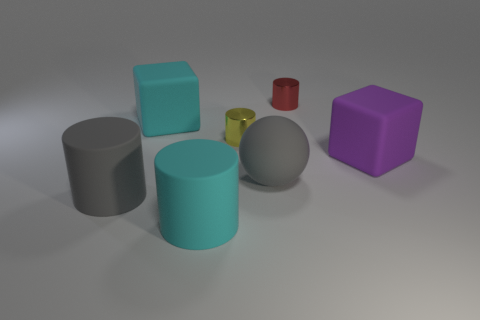What is the big gray cylinder in front of the metal cylinder on the left side of the shiny object that is right of the gray matte ball made of?
Keep it short and to the point. Rubber. Is the shape of the tiny object in front of the tiny red thing the same as the thing in front of the big gray rubber cylinder?
Keep it short and to the point. Yes. Is there a gray matte object of the same size as the cyan cube?
Offer a terse response. Yes. What number of red objects are either tiny cylinders or big balls?
Ensure brevity in your answer.  1. How many other balls are the same color as the large ball?
Ensure brevity in your answer.  0. Is there anything else that has the same shape as the yellow object?
Offer a very short reply. Yes. How many cubes are cyan matte objects or metallic things?
Provide a succinct answer. 1. The big block to the right of the big cyan rubber cylinder is what color?
Offer a terse response. Purple. What is the shape of the red thing that is the same size as the yellow object?
Make the answer very short. Cylinder. What number of tiny things are to the left of the cyan rubber cube?
Your answer should be compact. 0. 